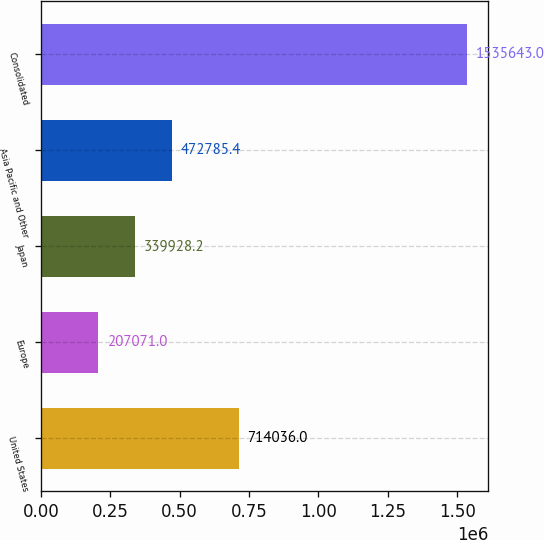Convert chart to OTSL. <chart><loc_0><loc_0><loc_500><loc_500><bar_chart><fcel>United States<fcel>Europe<fcel>Japan<fcel>Asia Pacific and Other<fcel>Consolidated<nl><fcel>714036<fcel>207071<fcel>339928<fcel>472785<fcel>1.53564e+06<nl></chart> 